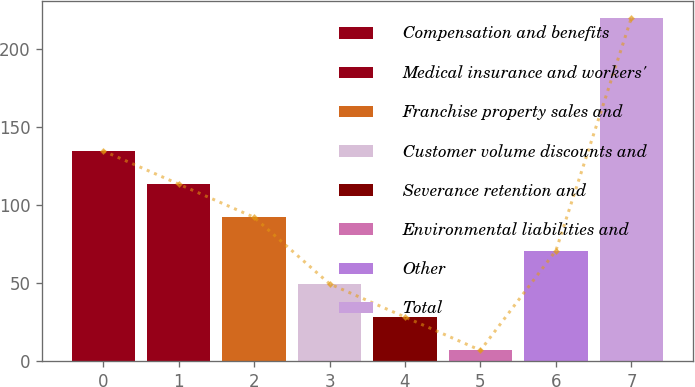<chart> <loc_0><loc_0><loc_500><loc_500><bar_chart><fcel>Compensation and benefits<fcel>Medical insurance and workers'<fcel>Franchise property sales and<fcel>Customer volume discounts and<fcel>Severance retention and<fcel>Environmental liabilities and<fcel>Other<fcel>Total<nl><fcel>134.84<fcel>113.55<fcel>92.26<fcel>49.68<fcel>28.39<fcel>7.1<fcel>70.97<fcel>220<nl></chart> 